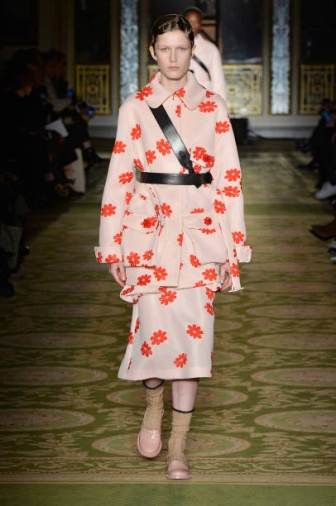What do you think the model is feeling while walking down the runway? The model likely exudes a mix of confidence and concentration as she walks down the runway. With the audience's eyes on her, she needs to maintain perfect poise and grace, focusing on her stride and the presentation of the outfit. There may also be an element of excitement, knowing she's showcasing a piece of art in an opulent setting. 